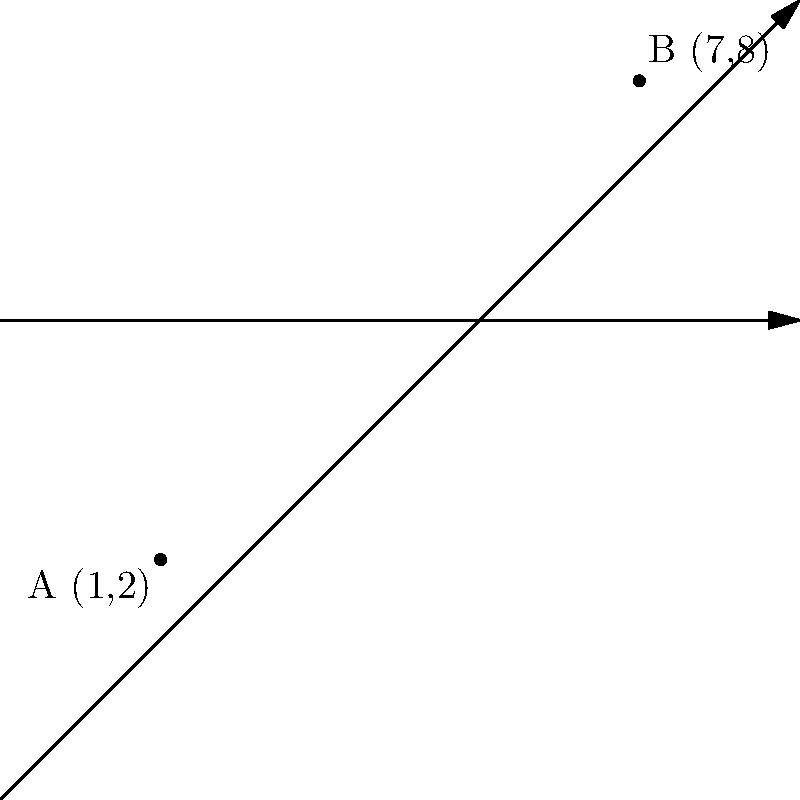On your vacation map, two popular tourist attractions are represented on a coordinate plane. Attraction A is located at (1,2) and attraction B is at (7,8). Calculate the distance between these two attractions to help plan your itinerary efficiently. To find the distance between two points on a coordinate plane, we can use the distance formula, which is derived from the Pythagorean theorem:

$$d = \sqrt{(x_2 - x_1)^2 + (y_2 - y_1)^2}$$

Where $(x_1, y_1)$ are the coordinates of the first point and $(x_2, y_2)$ are the coordinates of the second point.

Let's plug in our values:
$(x_1, y_1) = (1, 2)$ for Attraction A
$(x_2, y_2) = (7, 8)$ for Attraction B

Now, let's calculate step by step:

1) $d = \sqrt{(7 - 1)^2 + (8 - 2)^2}$

2) $d = \sqrt{6^2 + 6^2}$

3) $d = \sqrt{36 + 36}$

4) $d = \sqrt{72}$

5) $d = 6\sqrt{2}$

Therefore, the distance between Attraction A and Attraction B is $6\sqrt{2}$ units.
Answer: $6\sqrt{2}$ units 